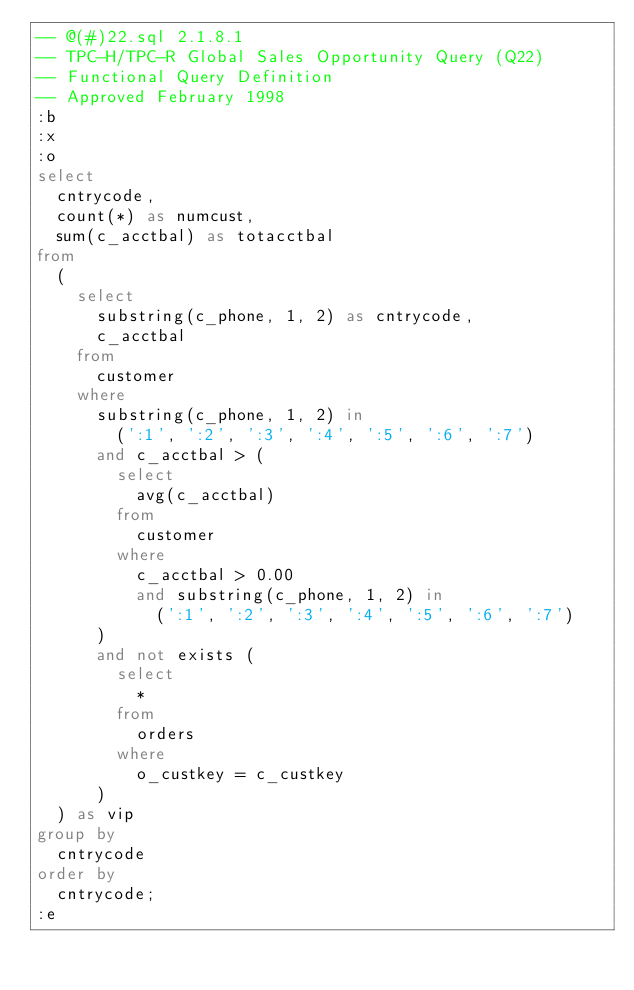<code> <loc_0><loc_0><loc_500><loc_500><_SQL_>-- @(#)22.sql	2.1.8.1
-- TPC-H/TPC-R Global Sales Opportunity Query (Q22)
-- Functional Query Definition
-- Approved February 1998
:b
:x
:o
select
	cntrycode,
	count(*) as numcust,
	sum(c_acctbal) as totacctbal
from
	(
		select
			substring(c_phone, 1, 2) as cntrycode,
			c_acctbal
		from
			customer
		where
			substring(c_phone, 1, 2) in
				(':1', ':2', ':3', ':4', ':5', ':6', ':7')
			and c_acctbal > (
				select
					avg(c_acctbal)
				from
					customer
				where
					c_acctbal > 0.00
					and substring(c_phone, 1, 2) in
						(':1', ':2', ':3', ':4', ':5', ':6', ':7')
			)
			and not exists (
				select
					*
				from
					orders
				where
					o_custkey = c_custkey
			)
	) as vip
group by
	cntrycode
order by
	cntrycode;
:e
</code> 